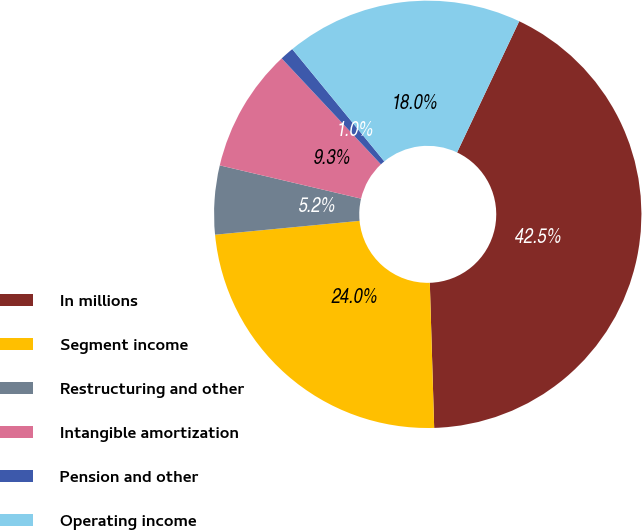Convert chart. <chart><loc_0><loc_0><loc_500><loc_500><pie_chart><fcel>In millions<fcel>Segment income<fcel>Restructuring and other<fcel>Intangible amortization<fcel>Pension and other<fcel>Operating income<nl><fcel>42.48%<fcel>23.96%<fcel>5.2%<fcel>9.34%<fcel>1.05%<fcel>17.97%<nl></chart> 